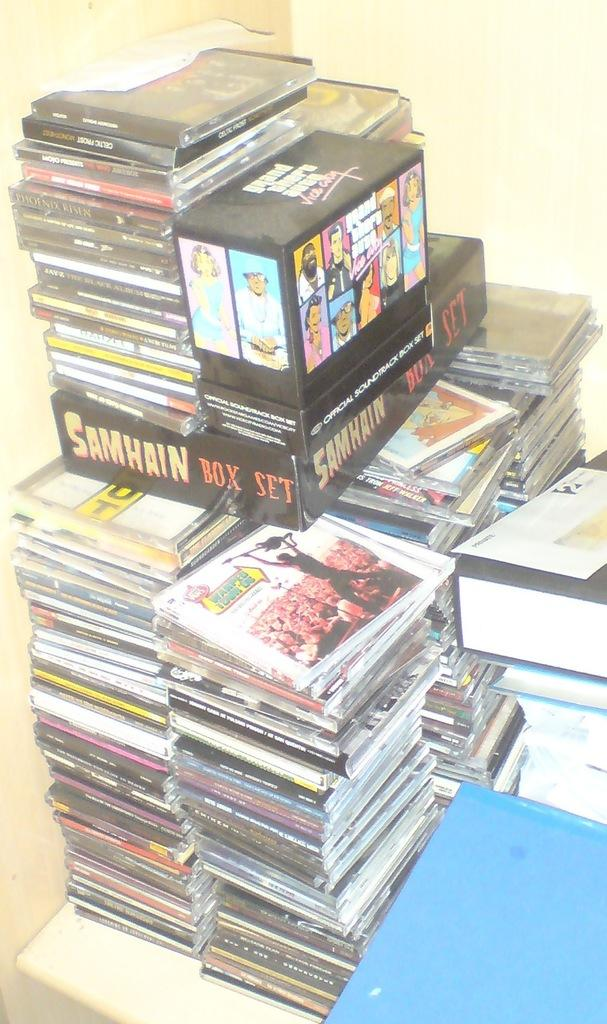Provide a one-sentence caption for the provided image. A Samhain Box Set sits on top of many CDs. 